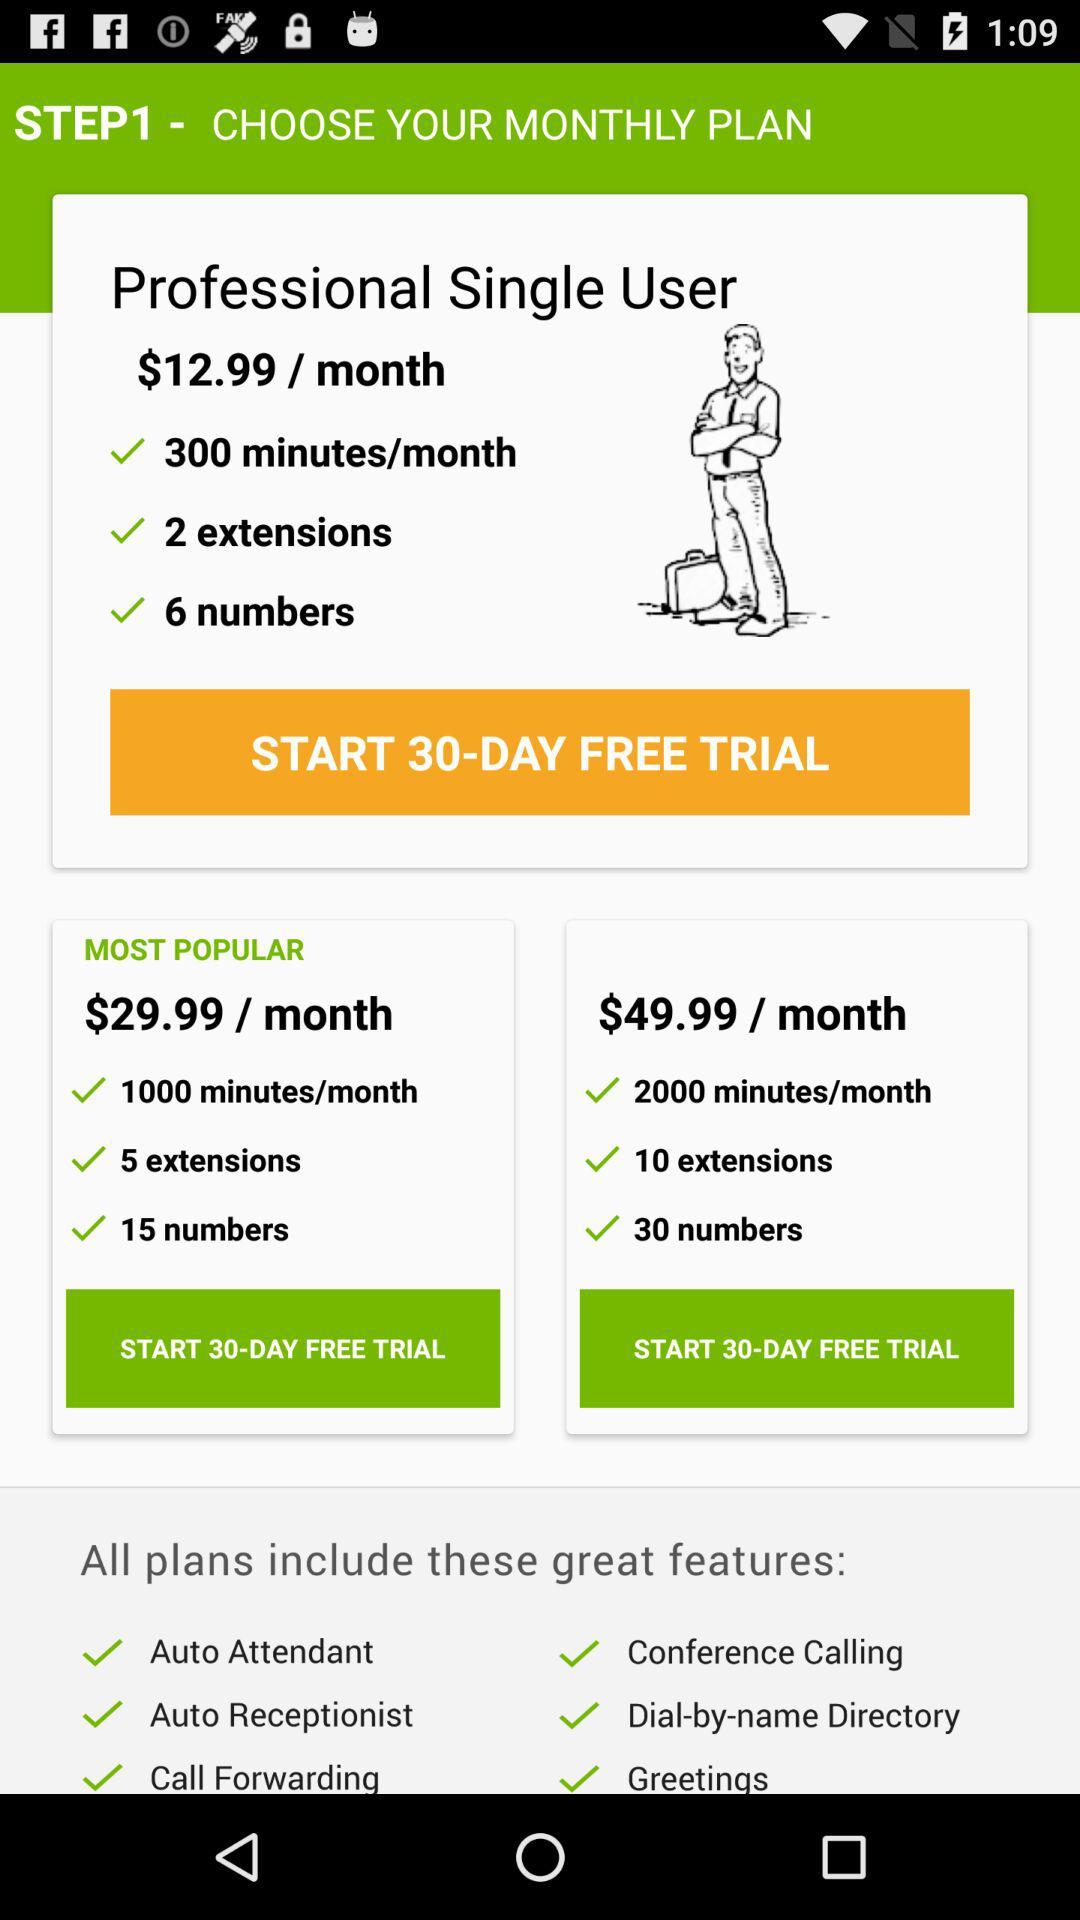Which plan has the option "1000 minutes/month"? "1000 minutes/month" is the option for the "MOST POPULAR" plan. 